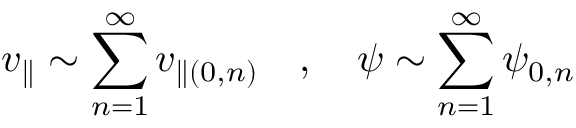Convert formula to latex. <formula><loc_0><loc_0><loc_500><loc_500>v _ { \| } \sim \sum _ { n = 1 } ^ { \infty } v _ { \| ( 0 , n ) } \quad , \quad \psi \sim \sum _ { n = 1 } ^ { \infty } \psi _ { 0 , n }</formula> 